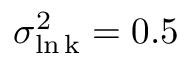<formula> <loc_0><loc_0><loc_500><loc_500>\sigma _ { \ln k } ^ { 2 } = 0 . 5</formula> 